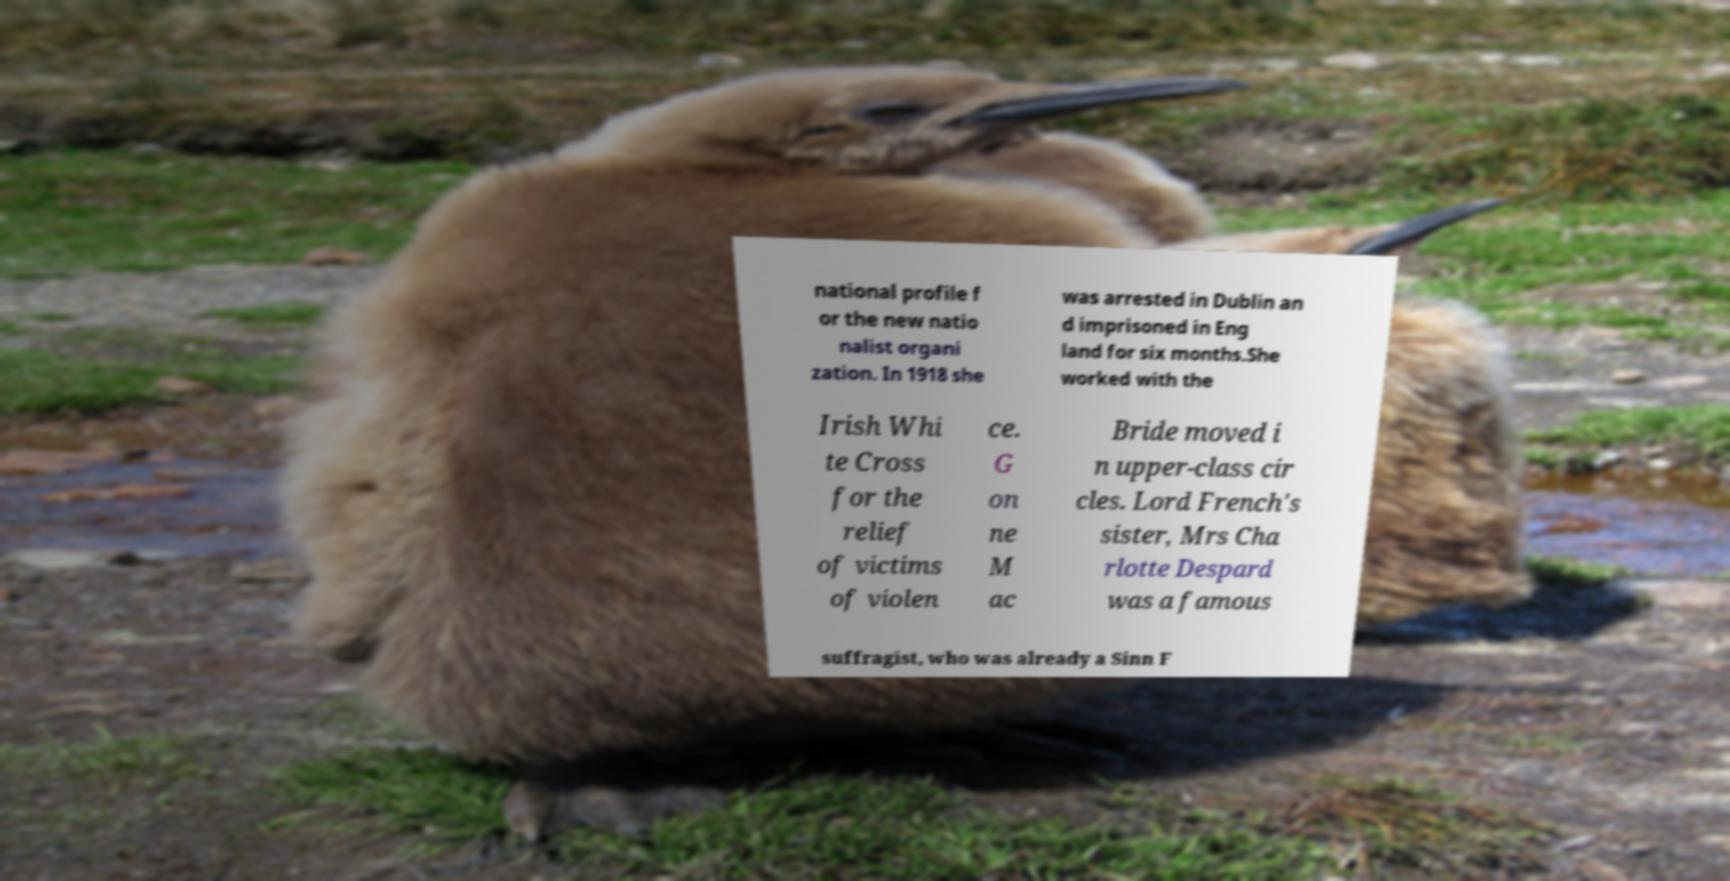What messages or text are displayed in this image? I need them in a readable, typed format. national profile f or the new natio nalist organi zation. In 1918 she was arrested in Dublin an d imprisoned in Eng land for six months.She worked with the Irish Whi te Cross for the relief of victims of violen ce. G on ne M ac Bride moved i n upper-class cir cles. Lord French's sister, Mrs Cha rlotte Despard was a famous suffragist, who was already a Sinn F 